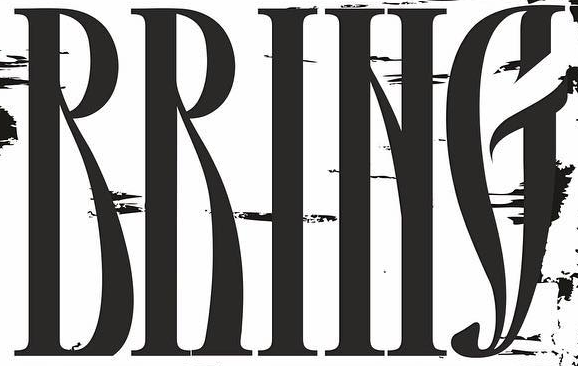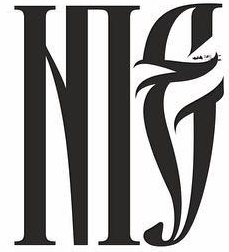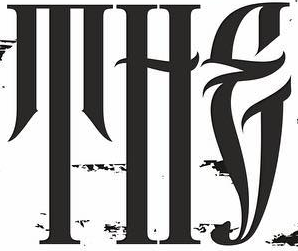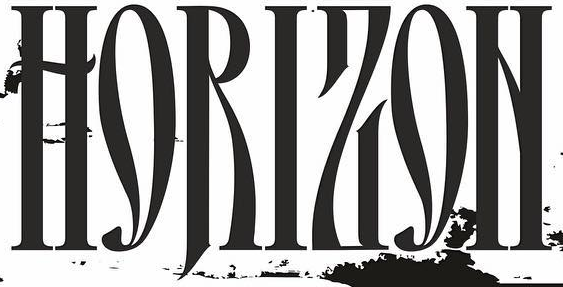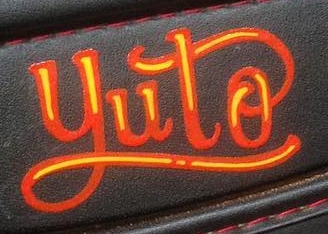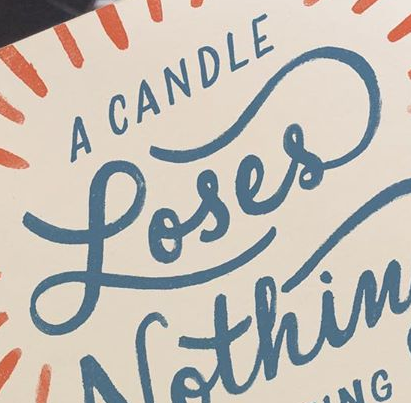Read the text content from these images in order, separated by a semicolon. RRING; NIE; THE; HORIZON; yuto; Loses 